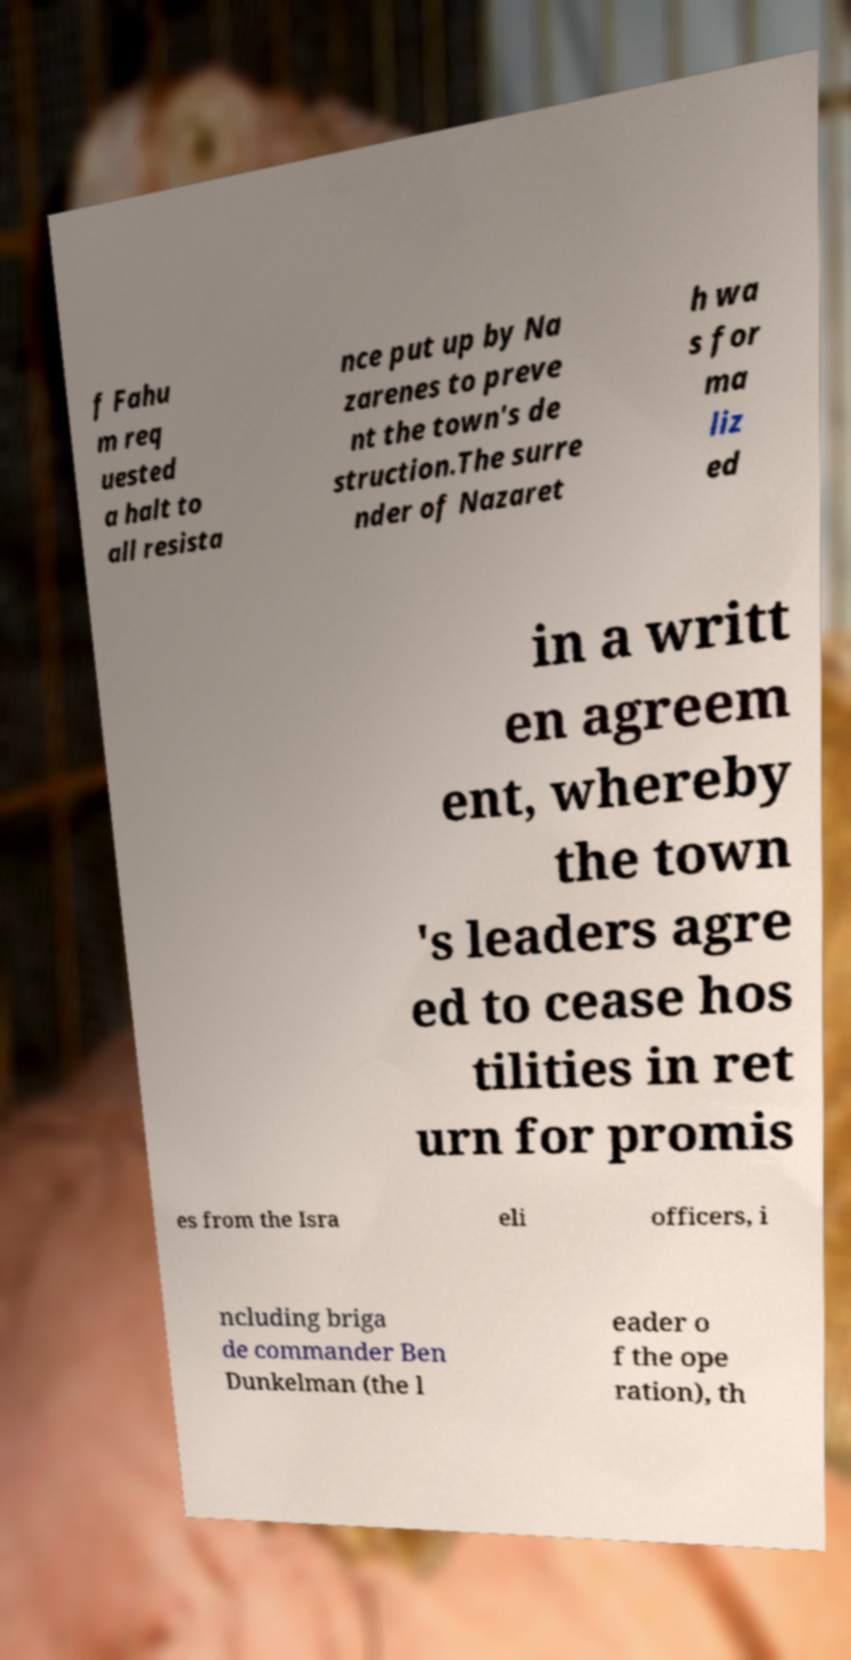There's text embedded in this image that I need extracted. Can you transcribe it verbatim? f Fahu m req uested a halt to all resista nce put up by Na zarenes to preve nt the town's de struction.The surre nder of Nazaret h wa s for ma liz ed in a writt en agreem ent, whereby the town 's leaders agre ed to cease hos tilities in ret urn for promis es from the Isra eli officers, i ncluding briga de commander Ben Dunkelman (the l eader o f the ope ration), th 